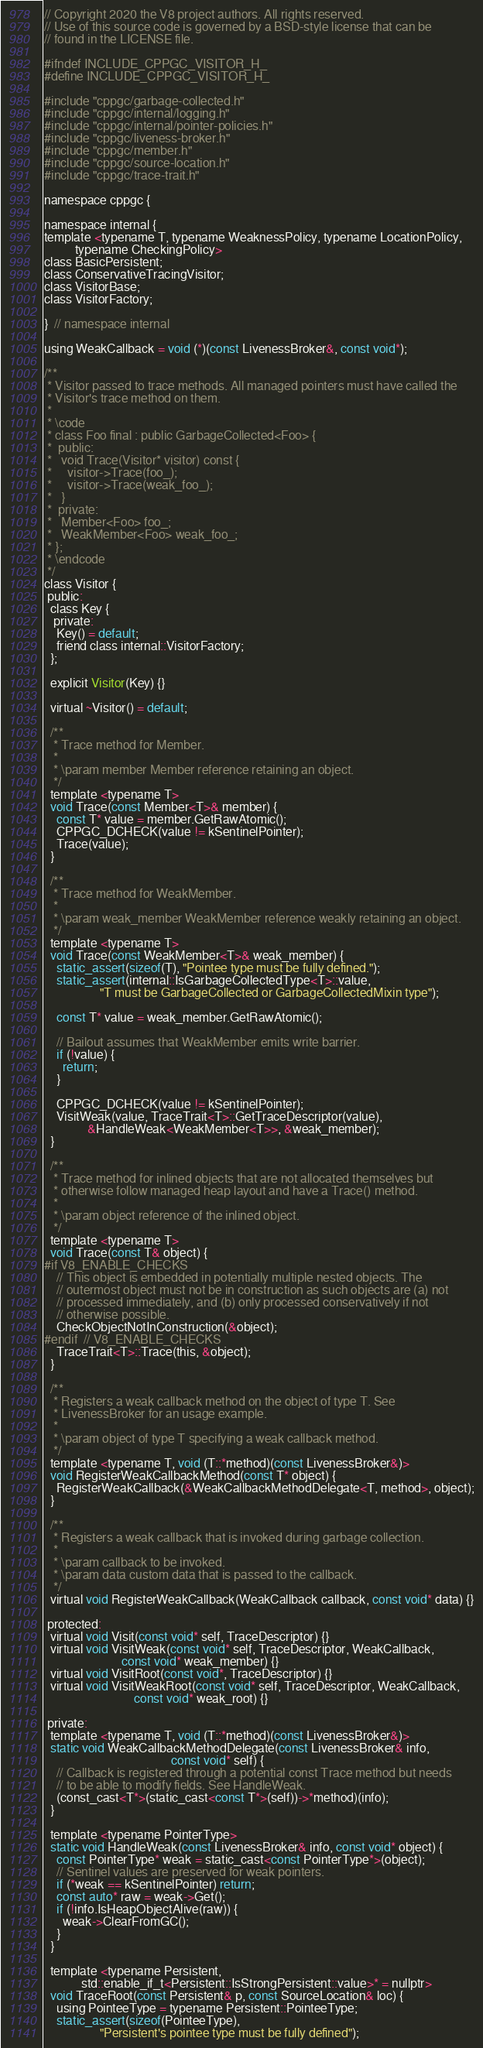<code> <loc_0><loc_0><loc_500><loc_500><_C_>// Copyright 2020 the V8 project authors. All rights reserved.
// Use of this source code is governed by a BSD-style license that can be
// found in the LICENSE file.

#ifndef INCLUDE_CPPGC_VISITOR_H_
#define INCLUDE_CPPGC_VISITOR_H_

#include "cppgc/garbage-collected.h"
#include "cppgc/internal/logging.h"
#include "cppgc/internal/pointer-policies.h"
#include "cppgc/liveness-broker.h"
#include "cppgc/member.h"
#include "cppgc/source-location.h"
#include "cppgc/trace-trait.h"

namespace cppgc {

namespace internal {
template <typename T, typename WeaknessPolicy, typename LocationPolicy,
          typename CheckingPolicy>
class BasicPersistent;
class ConservativeTracingVisitor;
class VisitorBase;
class VisitorFactory;

}  // namespace internal

using WeakCallback = void (*)(const LivenessBroker&, const void*);

/**
 * Visitor passed to trace methods. All managed pointers must have called the
 * Visitor's trace method on them.
 *
 * \code
 * class Foo final : public GarbageCollected<Foo> {
 *  public:
 *   void Trace(Visitor* visitor) const {
 *     visitor->Trace(foo_);
 *     visitor->Trace(weak_foo_);
 *   }
 *  private:
 *   Member<Foo> foo_;
 *   WeakMember<Foo> weak_foo_;
 * };
 * \endcode
 */
class Visitor {
 public:
  class Key {
   private:
    Key() = default;
    friend class internal::VisitorFactory;
  };

  explicit Visitor(Key) {}

  virtual ~Visitor() = default;

  /**
   * Trace method for Member.
   *
   * \param member Member reference retaining an object.
   */
  template <typename T>
  void Trace(const Member<T>& member) {
    const T* value = member.GetRawAtomic();
    CPPGC_DCHECK(value != kSentinelPointer);
    Trace(value);
  }

  /**
   * Trace method for WeakMember.
   *
   * \param weak_member WeakMember reference weakly retaining an object.
   */
  template <typename T>
  void Trace(const WeakMember<T>& weak_member) {
    static_assert(sizeof(T), "Pointee type must be fully defined.");
    static_assert(internal::IsGarbageCollectedType<T>::value,
                  "T must be GarbageCollected or GarbageCollectedMixin type");

    const T* value = weak_member.GetRawAtomic();

    // Bailout assumes that WeakMember emits write barrier.
    if (!value) {
      return;
    }

    CPPGC_DCHECK(value != kSentinelPointer);
    VisitWeak(value, TraceTrait<T>::GetTraceDescriptor(value),
              &HandleWeak<WeakMember<T>>, &weak_member);
  }

  /**
   * Trace method for inlined objects that are not allocated themselves but
   * otherwise follow managed heap layout and have a Trace() method.
   *
   * \param object reference of the inlined object.
   */
  template <typename T>
  void Trace(const T& object) {
#if V8_ENABLE_CHECKS
    // This object is embedded in potentially multiple nested objects. The
    // outermost object must not be in construction as such objects are (a) not
    // processed immediately, and (b) only processed conservatively if not
    // otherwise possible.
    CheckObjectNotInConstruction(&object);
#endif  // V8_ENABLE_CHECKS
    TraceTrait<T>::Trace(this, &object);
  }

  /**
   * Registers a weak callback method on the object of type T. See
   * LivenessBroker for an usage example.
   *
   * \param object of type T specifying a weak callback method.
   */
  template <typename T, void (T::*method)(const LivenessBroker&)>
  void RegisterWeakCallbackMethod(const T* object) {
    RegisterWeakCallback(&WeakCallbackMethodDelegate<T, method>, object);
  }

  /**
   * Registers a weak callback that is invoked during garbage collection.
   *
   * \param callback to be invoked.
   * \param data custom data that is passed to the callback.
   */
  virtual void RegisterWeakCallback(WeakCallback callback, const void* data) {}

 protected:
  virtual void Visit(const void* self, TraceDescriptor) {}
  virtual void VisitWeak(const void* self, TraceDescriptor, WeakCallback,
                         const void* weak_member) {}
  virtual void VisitRoot(const void*, TraceDescriptor) {}
  virtual void VisitWeakRoot(const void* self, TraceDescriptor, WeakCallback,
                             const void* weak_root) {}

 private:
  template <typename T, void (T::*method)(const LivenessBroker&)>
  static void WeakCallbackMethodDelegate(const LivenessBroker& info,
                                         const void* self) {
    // Callback is registered through a potential const Trace method but needs
    // to be able to modify fields. See HandleWeak.
    (const_cast<T*>(static_cast<const T*>(self))->*method)(info);
  }

  template <typename PointerType>
  static void HandleWeak(const LivenessBroker& info, const void* object) {
    const PointerType* weak = static_cast<const PointerType*>(object);
    // Sentinel values are preserved for weak pointers.
    if (*weak == kSentinelPointer) return;
    const auto* raw = weak->Get();
    if (!info.IsHeapObjectAlive(raw)) {
      weak->ClearFromGC();
    }
  }

  template <typename Persistent,
            std::enable_if_t<Persistent::IsStrongPersistent::value>* = nullptr>
  void TraceRoot(const Persistent& p, const SourceLocation& loc) {
    using PointeeType = typename Persistent::PointeeType;
    static_assert(sizeof(PointeeType),
                  "Persistent's pointee type must be fully defined");</code> 